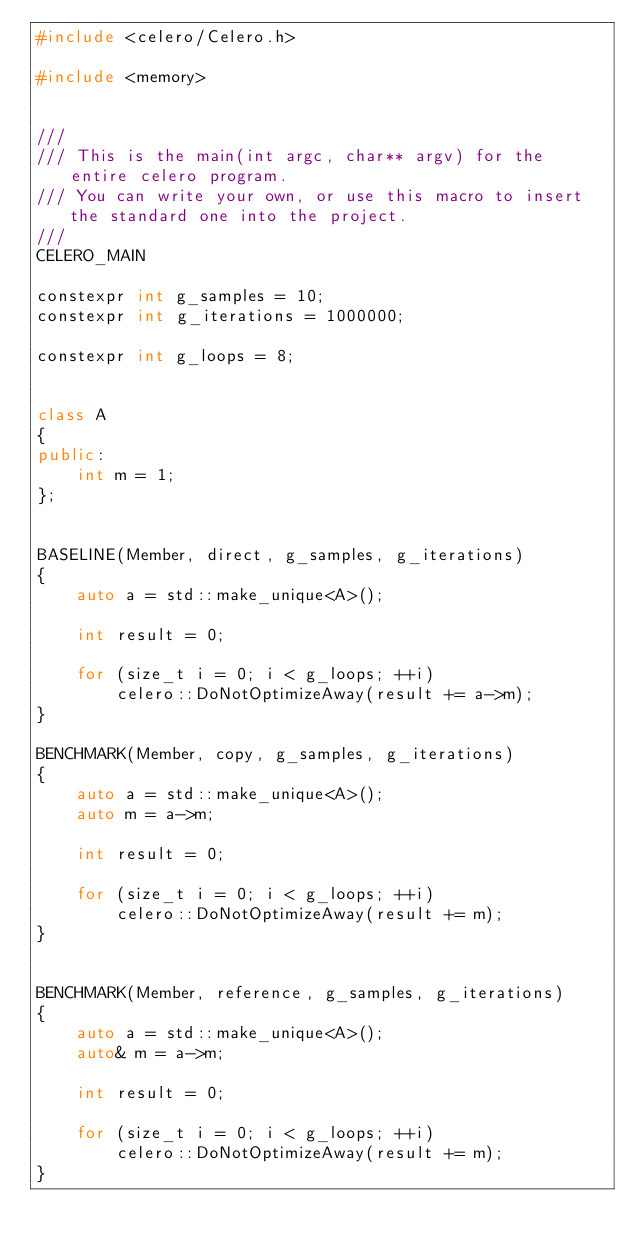Convert code to text. <code><loc_0><loc_0><loc_500><loc_500><_C++_>#include <celero/Celero.h>

#include <memory>


///
/// This is the main(int argc, char** argv) for the entire celero program.
/// You can write your own, or use this macro to insert the standard one into the project.
///
CELERO_MAIN

constexpr int g_samples = 10;
constexpr int g_iterations = 1000000;

constexpr int g_loops = 8;


class A
{
public:
	int m = 1;
};


BASELINE(Member, direct, g_samples, g_iterations)
{
	auto a = std::make_unique<A>();

	int result = 0;

	for (size_t i = 0; i < g_loops; ++i)
		celero::DoNotOptimizeAway(result += a->m);
}

BENCHMARK(Member, copy, g_samples, g_iterations)
{
	auto a = std::make_unique<A>();
	auto m = a->m;

	int result = 0;

	for (size_t i = 0; i < g_loops; ++i)
		celero::DoNotOptimizeAway(result += m);
}


BENCHMARK(Member, reference, g_samples, g_iterations)
{
	auto a = std::make_unique<A>();
	auto& m = a->m;

	int result = 0;

	for (size_t i = 0; i < g_loops; ++i)
		celero::DoNotOptimizeAway(result += m);
}</code> 